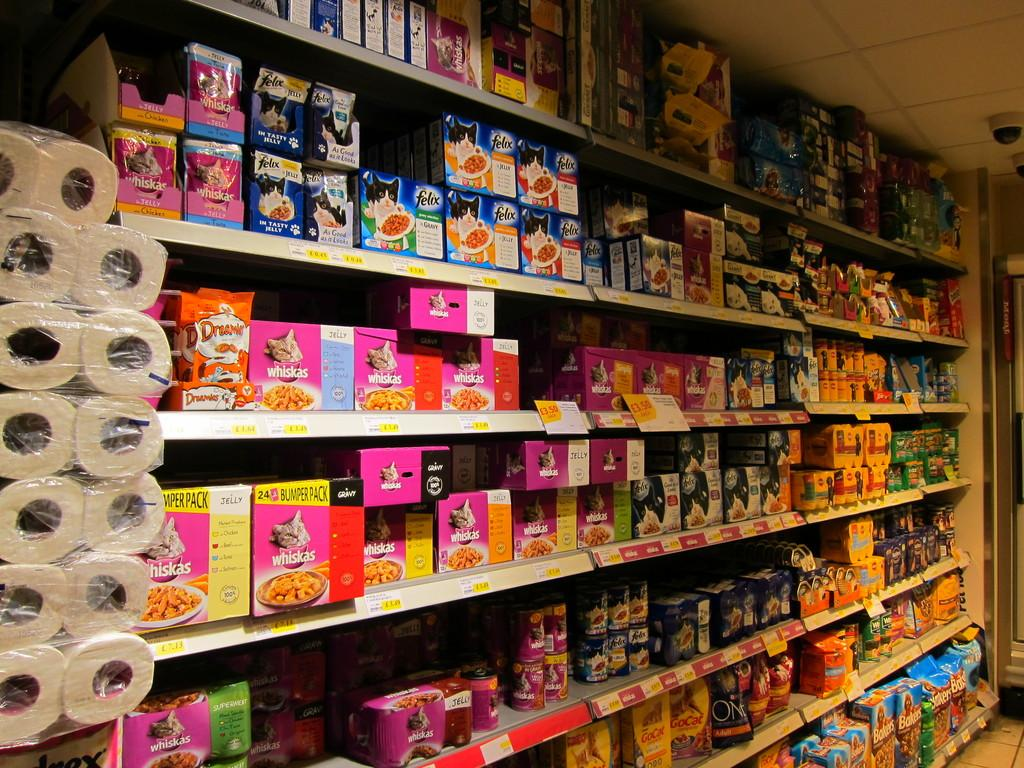<image>
Present a compact description of the photo's key features. The pet food isle at a store has brands like Whiskas and Felix on display. 